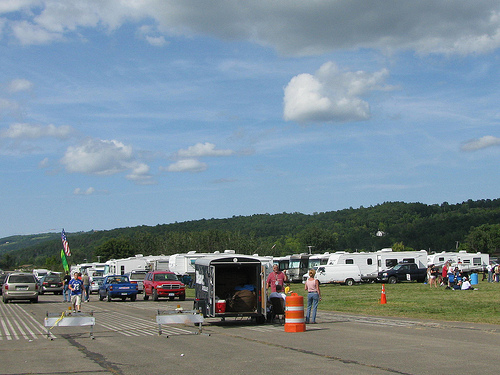<image>
Can you confirm if the car is on the road? Yes. Looking at the image, I can see the car is positioned on top of the road, with the road providing support. Is the cone in front of the trailer? Yes. The cone is positioned in front of the trailer, appearing closer to the camera viewpoint. 